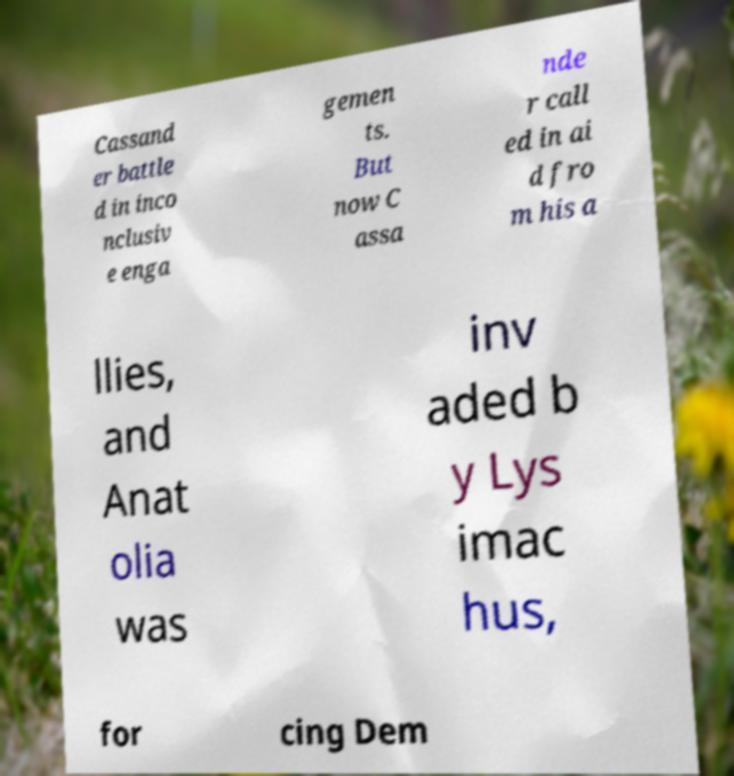There's text embedded in this image that I need extracted. Can you transcribe it verbatim? Cassand er battle d in inco nclusiv e enga gemen ts. But now C assa nde r call ed in ai d fro m his a llies, and Anat olia was inv aded b y Lys imac hus, for cing Dem 